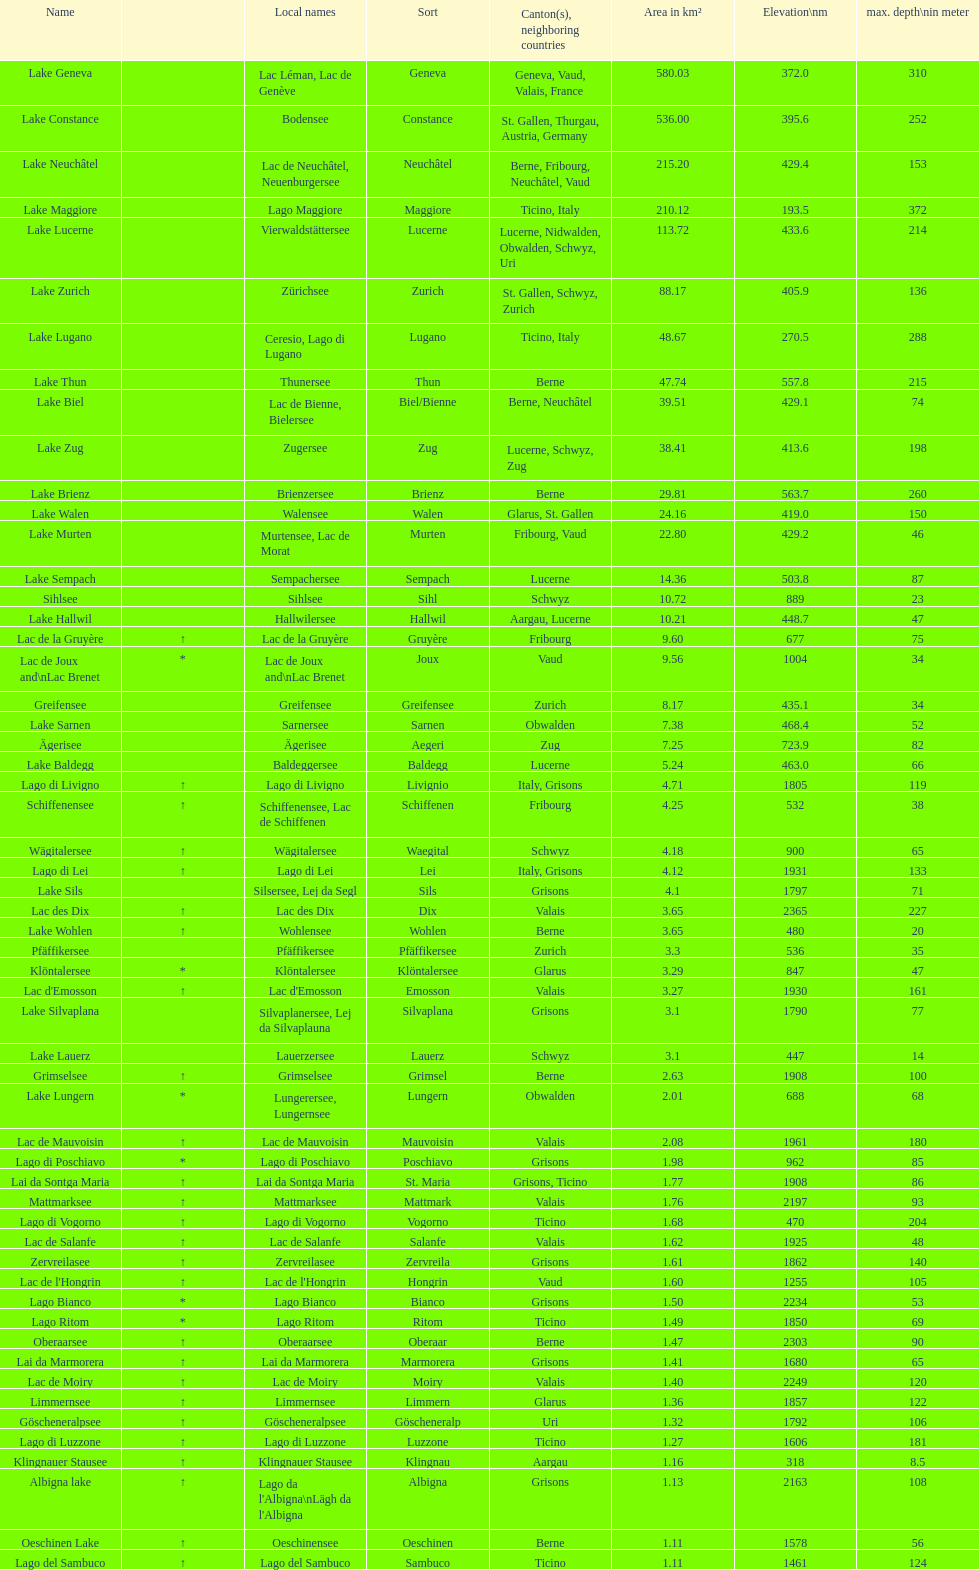Which lake possesses the highest elevation? Lac des Dix. 